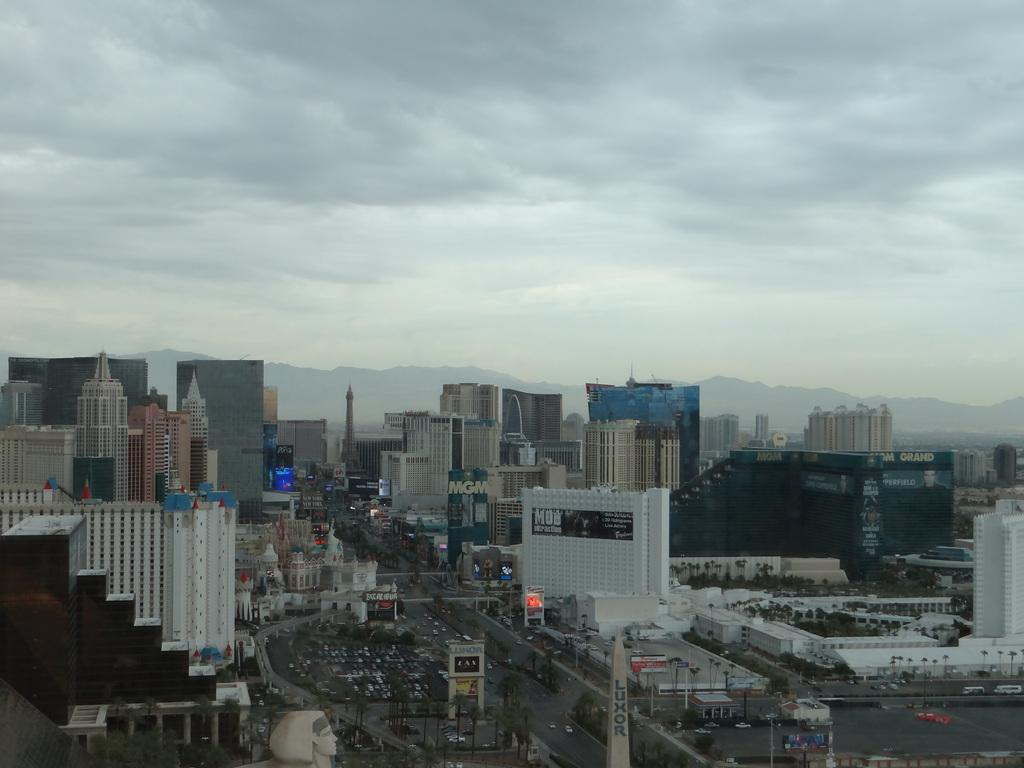What type of structures can be seen in the image? There are many buildings in the image. What else can be seen besides the buildings? There is a road visible in the image, and there are trees present as well. Can you describe any specific features on the buildings? A: Name boards are present on some of the buildings. What is visible in the background of the image? There are trees and the sky visible in the background of the image. What type of honey can be seen dripping from the guitar in the image? There is no guitar or honey present in the image. 